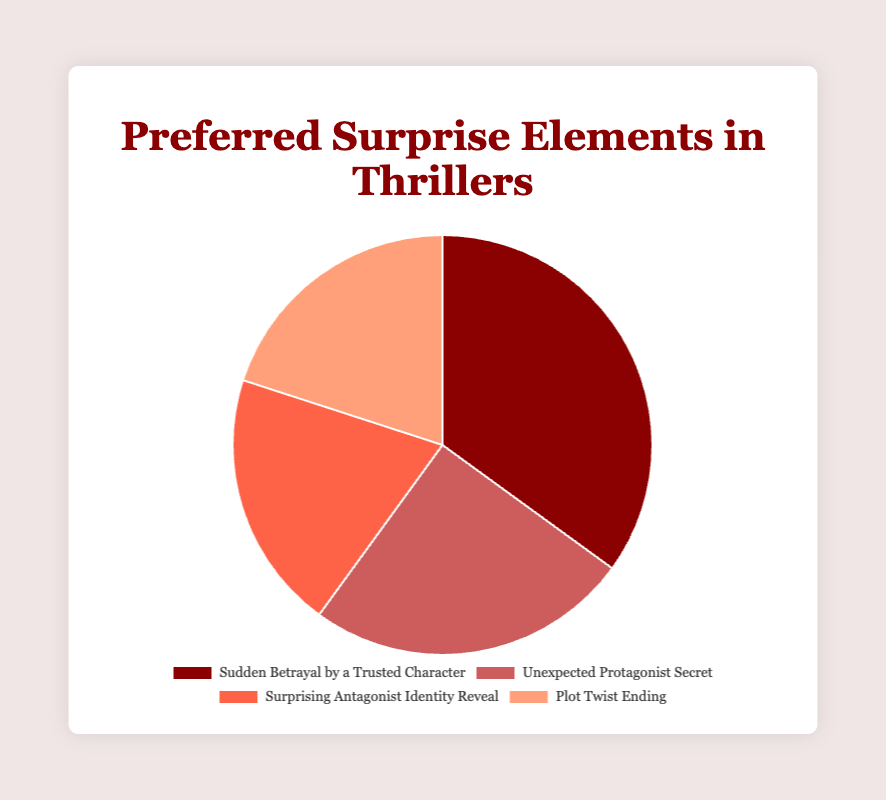Which surprise element has the highest reader satisfaction rate? The element "Sudden Betrayal by a Trusted Character" has the highest percentage at 35%, indicating it is the most preferred surprise element.
Answer: Sudden Betrayal by a Trusted Character Which two surprise elements have the same reader satisfaction rate? Both "Surprising Antagonist Identity Reveal" and "Plot Twist Ending" have a reader satisfaction rate of 20%. They are equally preferred by readers.
Answer: Surprising Antagonist Identity Reveal and Plot Twist Ending What is the combined satisfaction rate for "Surprising Antagonist Identity Reveal" and "Plot Twist Ending"? The satisfaction rates for both elements are 20%. Adding them together gives 20% + 20% = 40%.
Answer: 40% How much higher is the satisfaction rate for "Sudden Betrayal by a Trusted Character" compared to "Unexpected Protagonist Secret"? The satisfaction rate for "Sudden Betrayal" is 35%, and for "Unexpected Protagonist Secret" it is 25%. The difference is 35% - 25% = 10%.
Answer: 10% What percentage of the total satisfaction rate do the two least preferred elements account for? The two least preferred elements are "Surprising Antagonist Identity Reveal" and "Plot Twist Ending", both with 20%. The combined percentage is 20% + 20% = 40%.
Answer: 40% Which element has a satisfaction rate that is 10% less than "Sudden Betrayal by a Trusted Character"? "Unexpected Protagonist Secret" has a satisfaction rate of 25%, which is 10% less than the 35% of "Sudden Betrayal by a Trusted Character".
Answer: Unexpected Protagonist Secret What is the average satisfaction rate of all surprise elements? Summing all percentages: 35% + 25% + 20% + 20% = 100%. There are 4 elements, so the average is 100% / 4 = 25%.
Answer: 25% Considering all surprise elements, what is the median satisfaction rate? Arranging the rates in ascending order: 20%, 20%, 25%, 35%. Since there is an even number of elements, the median is the average of the two middle numbers: (20% + 25%) / 2 = 22.5%.
Answer: 22.5% What is the difference between the highest and lowest satisfaction rates? The highest satisfaction rate is 35% (Sudden Betrayal by a Trusted Character), and the lowest is 20% (Surprising Antagonist Identity Reveal and Plot Twist Ending). The difference is 35% - 20% = 15%.
Answer: 15% 